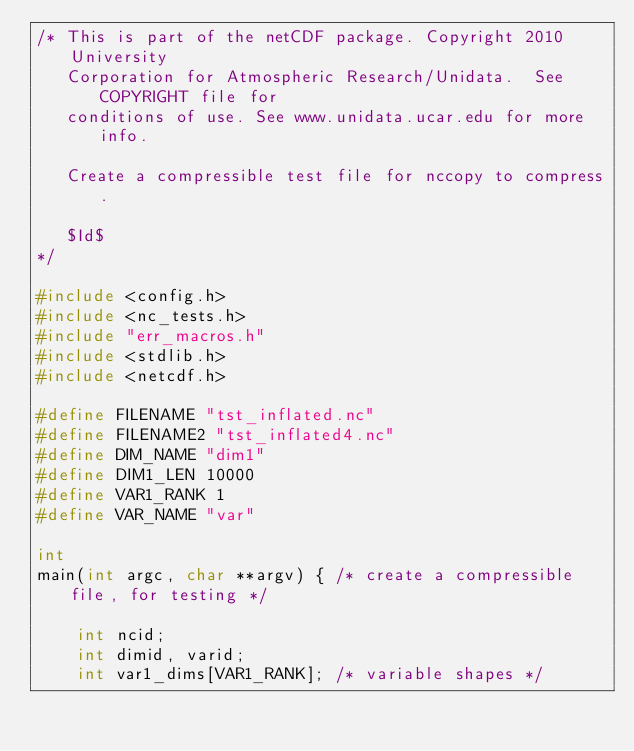Convert code to text. <code><loc_0><loc_0><loc_500><loc_500><_C_>/* This is part of the netCDF package. Copyright 2010 University
   Corporation for Atmospheric Research/Unidata.  See COPYRIGHT file for
   conditions of use. See www.unidata.ucar.edu for more info.

   Create a compressible test file for nccopy to compress.

   $Id$
*/

#include <config.h>
#include <nc_tests.h>
#include "err_macros.h"
#include <stdlib.h>
#include <netcdf.h>

#define FILENAME "tst_inflated.nc"
#define FILENAME2 "tst_inflated4.nc"
#define DIM_NAME "dim1"
#define DIM1_LEN 10000
#define VAR1_RANK 1
#define VAR_NAME "var"

int
main(int argc, char **argv) { /* create a compressible file, for testing */

    int ncid;
    int dimid, varid;
    int var1_dims[VAR1_RANK];	/* variable shapes */</code> 